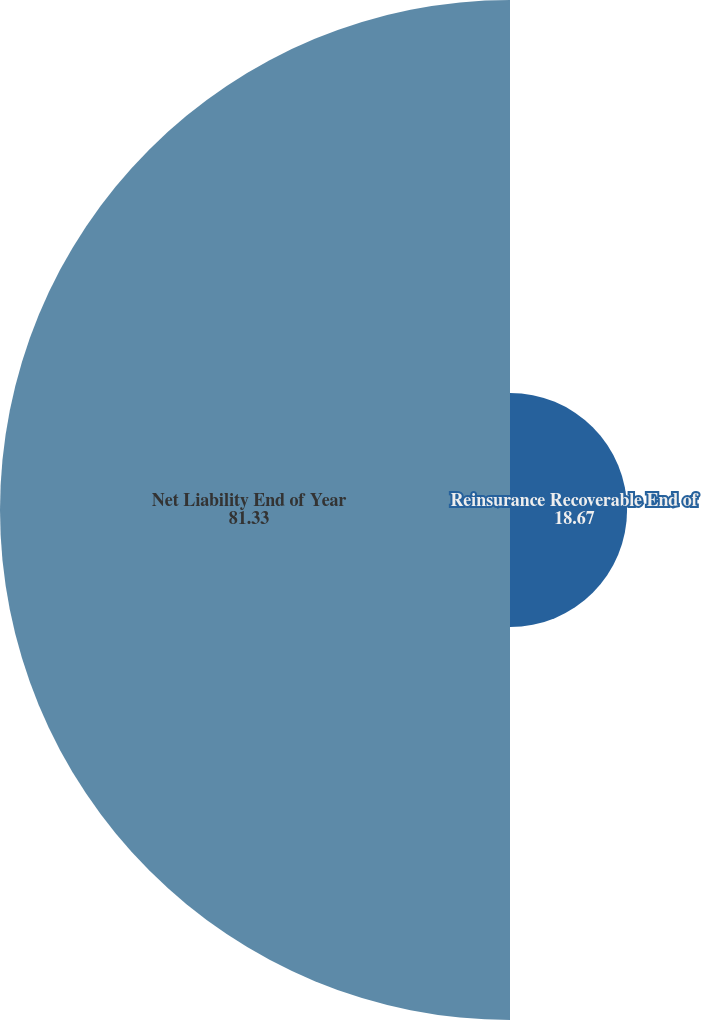Convert chart. <chart><loc_0><loc_0><loc_500><loc_500><pie_chart><fcel>Reinsurance Recoverable End of<fcel>Net Liability End of Year<nl><fcel>18.67%<fcel>81.33%<nl></chart> 